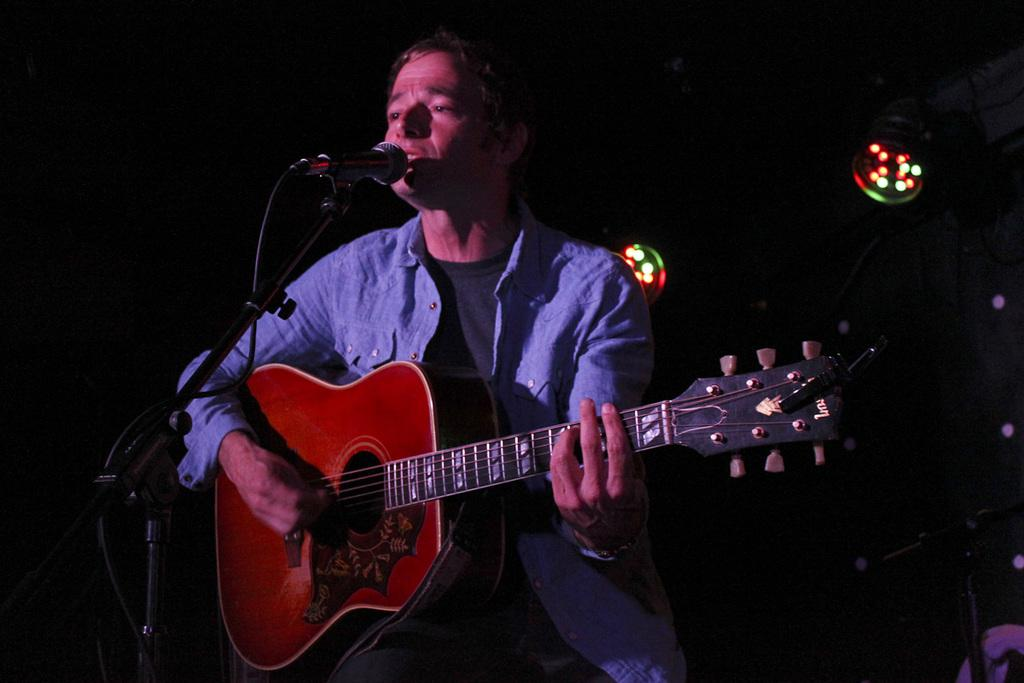Who is the main subject in the image? There is a man in the image. What is the man holding in the image? The man is holding a guitar. What is the man doing with the microphone in the image? The man is singing on a microphone. How many snails can be seen crawling on the guitar in the image? There are no snails present in the image; the man is holding a guitar. What type of friction is being generated by the man's voice on the microphone in the image? The image does not provide information about the type of friction generated by the man's voice on the microphone. 